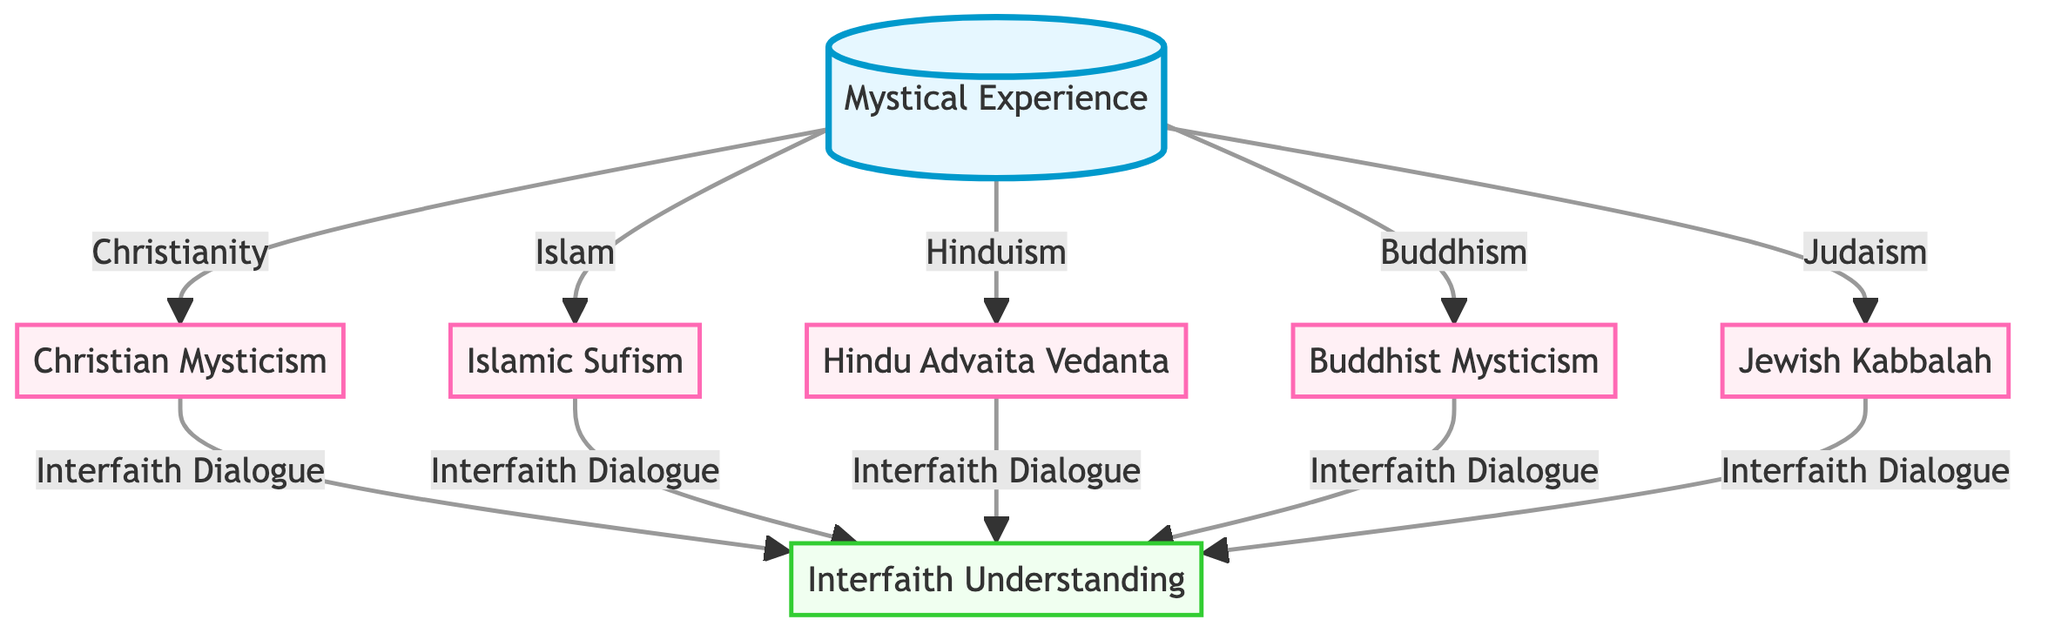What is the central concept depicted in the diagram? The central node of the diagram is labeled "Mystical Experience," indicating that this is the main focus or theme that connects the other elements presented.
Answer: Mystical Experience How many religious traditions are represented in the diagram? There are five distinct religious traditions presented, each linked to the central concept of "Mystical Experience." These are Christian Mysticism, Islamic Sufism, Hindu Advaita Vedanta, Buddhist Mysticism, and Jewish Kabbalah.
Answer: 5 Which religious tradition is specifically linked to the concept of Interfaith Dialogue? All five religious traditions (Christian Mysticism, Islamic Sufism, Hindu Advaita Vedanta, Buddhist Mysticism, and Jewish Kabbalah) connect to the central node and then branch out to the node representing "Interfaith Dialogue," indicating their engagement in interfaith understanding.
Answer: All What do the nodes representing the religious traditions have in common? Each of the religious tradition nodes is connected to the central node "Mystical Experience," indicating that they are all related to this core concept.
Answer: Connection to Mystical Experience Which node reflects an aspect of collaborative understanding among religions? The node labeled "Interfaith Understanding" represents the collaborative aspect among different religions as it is linked to all the religious traditions shown in the diagram, showcasing an effort towards dialogue and cooperation.
Answer: Interfaith Understanding How many total edges connect the central node to the religious traditions? The central node "Mystical Experience" has five direct connections to each of the religious traditions, which means there are five edges leading from it to those nodes.
Answer: 5 What color is used to distinguish the central concept in the diagram? The central node, "Mystical Experience," is filled with a light blue color denoting its importance in the diagram compared to other nodes.
Answer: Light Blue What do the edges connecting the religious traditions to the Interfaith Understanding node signify? The edges from each religious tradition to the "Interfaith Understanding" node symbolize the theme of dialogue and cooperation among various faiths, highlighting their common goal toward interfaith connections.
Answer: Dialogue and Cooperation 